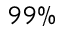<formula> <loc_0><loc_0><loc_500><loc_500>9 9 \%</formula> 